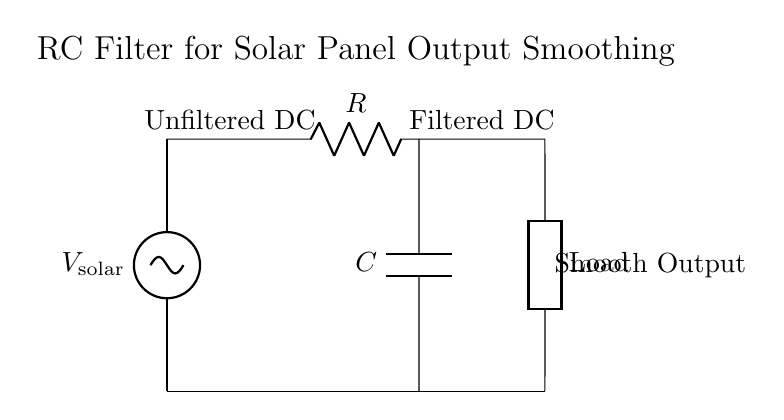What is the type of the first component in the circuit? The first component in the circuit is a solar panel, depicted as a voltage source (V_solar). This is identified by the label attached to the component in the diagram.
Answer: solar panel What does the capacitor in the circuit do? The capacitor is used to smooth the output by filtering out voltage fluctuations coming from the solar panel. It stores charge and releases it when there is a drop in voltage, thereby providing a steadier output.
Answer: smooth output What is the function of the resistor in this circuit? The resistor limits the current flow through the circuit. In RC circuits, it also helps in determining the time constant, which affects how quickly the capacitor charges and discharges.
Answer: limit current What is the output voltage type after the RC filter? The output voltage after the RC filter is a filtered DC. This means that the fluctuations from the input voltage have been smoothed out, leading to a more stable output.
Answer: filtered DC How does the capacitor affect the response time of the output? The capacitor introduces a time constant, defined as the product of resistance and capacitance (R*C), which determines how quickly the capacitor charges and discharges. A larger time constant means a slower response to changes in voltage.
Answer: determines response time What type of load is connected at the output? The load connected at the output is classified as a generic load, which could refer to any device or component that draws power from the circuit. The diagram labels it simply as 'Load'.
Answer: generic load 